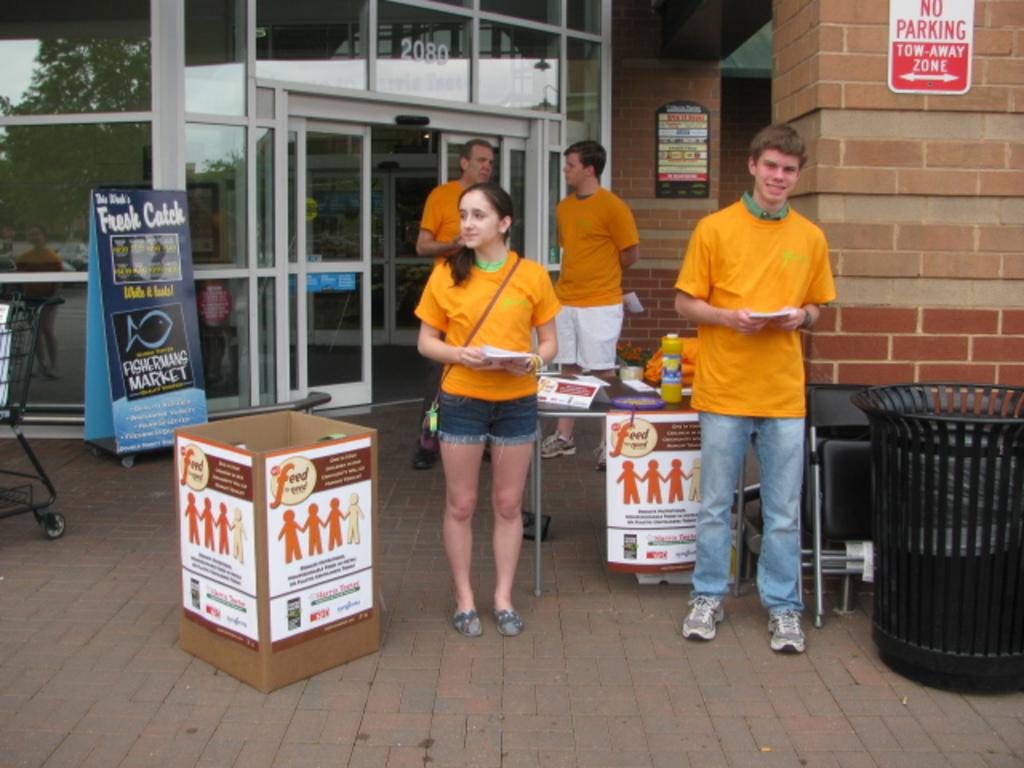Is there parking allowed in this area?
Provide a short and direct response. No. What color shirts is everyone wearing?
Ensure brevity in your answer.  Answering does not require reading text in the image. 